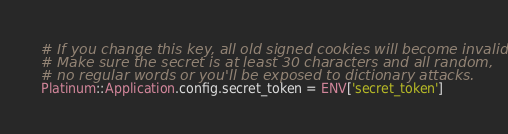<code> <loc_0><loc_0><loc_500><loc_500><_Ruby_># If you change this key, all old signed cookies will become invalid!
# Make sure the secret is at least 30 characters and all random,
# no regular words or you'll be exposed to dictionary attacks.
Platinum::Application.config.secret_token = ENV['secret_token']
</code> 